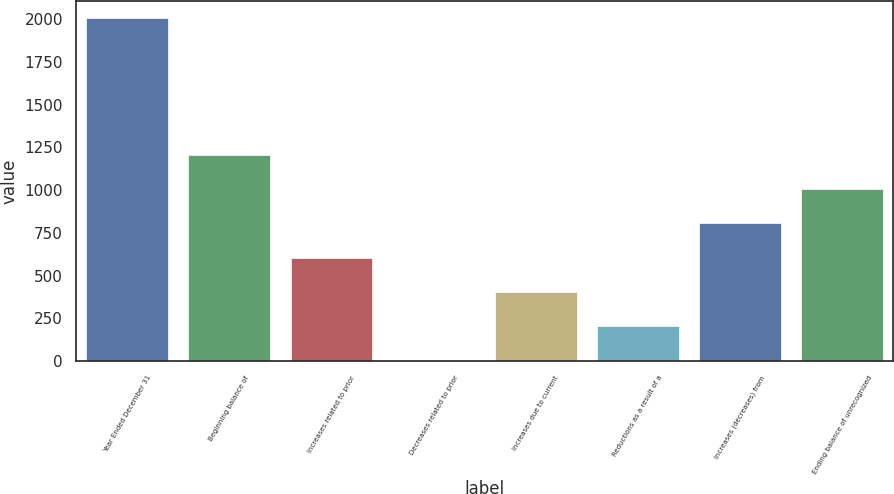Convert chart. <chart><loc_0><loc_0><loc_500><loc_500><bar_chart><fcel>Year Ended December 31<fcel>Beginning balance of<fcel>Increases related to prior<fcel>Decreases related to prior<fcel>Increases due to current<fcel>Reductions as a result of a<fcel>Increases (decreases) from<fcel>Ending balance of unrecognized<nl><fcel>2008<fcel>1206.4<fcel>605.2<fcel>4<fcel>404.8<fcel>204.4<fcel>805.6<fcel>1006<nl></chart> 